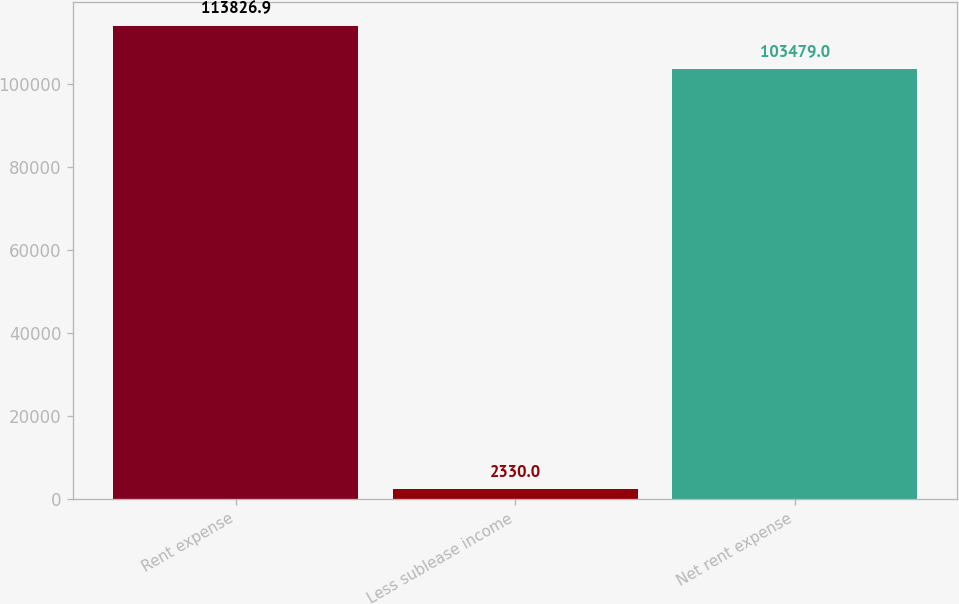<chart> <loc_0><loc_0><loc_500><loc_500><bar_chart><fcel>Rent expense<fcel>Less sublease income<fcel>Net rent expense<nl><fcel>113827<fcel>2330<fcel>103479<nl></chart> 